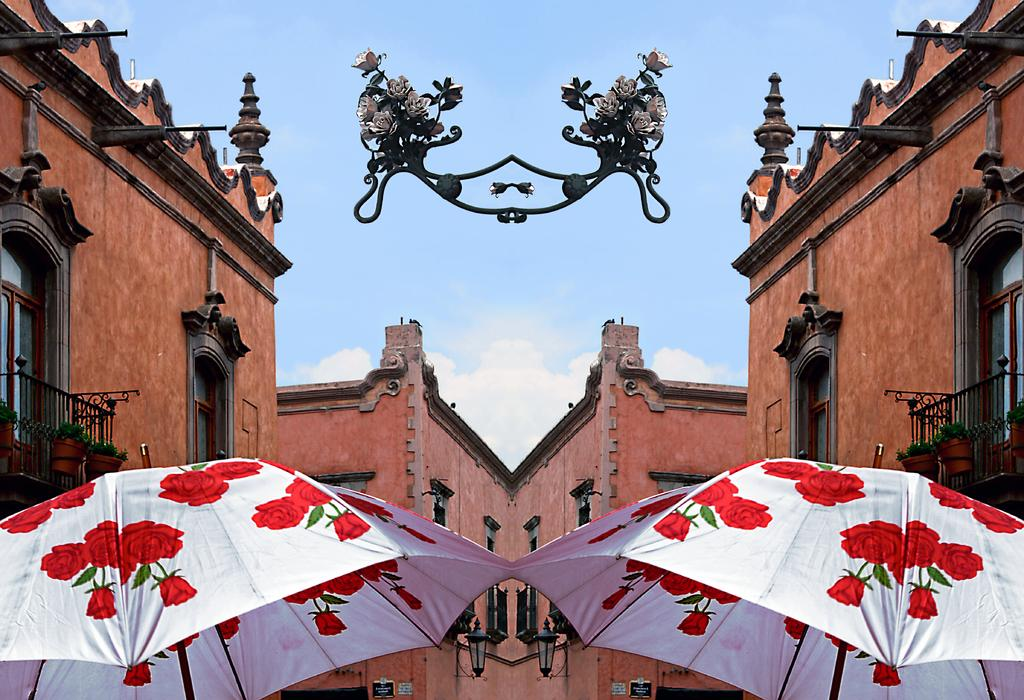What type of structures can be seen in the image? There are buildings in the image. What objects are present that might be used for cooking? There are grills in the image. What type of plants are visible in the image? There are houseplants in the image. What objects are present that might be used for providing shade? There are umbrellas in the image. What is visible at the top of the image? The sky is visible in the image. What can be seen in the sky in the image? There are clouds in the sky. How many eggs are visible in the image? There are no eggs present in the image. What type of vest is being worn by the houseplants in the image? There are no vests present in the image, as houseplants are not capable of wearing clothing. What shape is formed by the arrangement of the buildings in the image? The provided facts do not give enough information to determine the shape formed by the arrangement of the buildings in the image. 